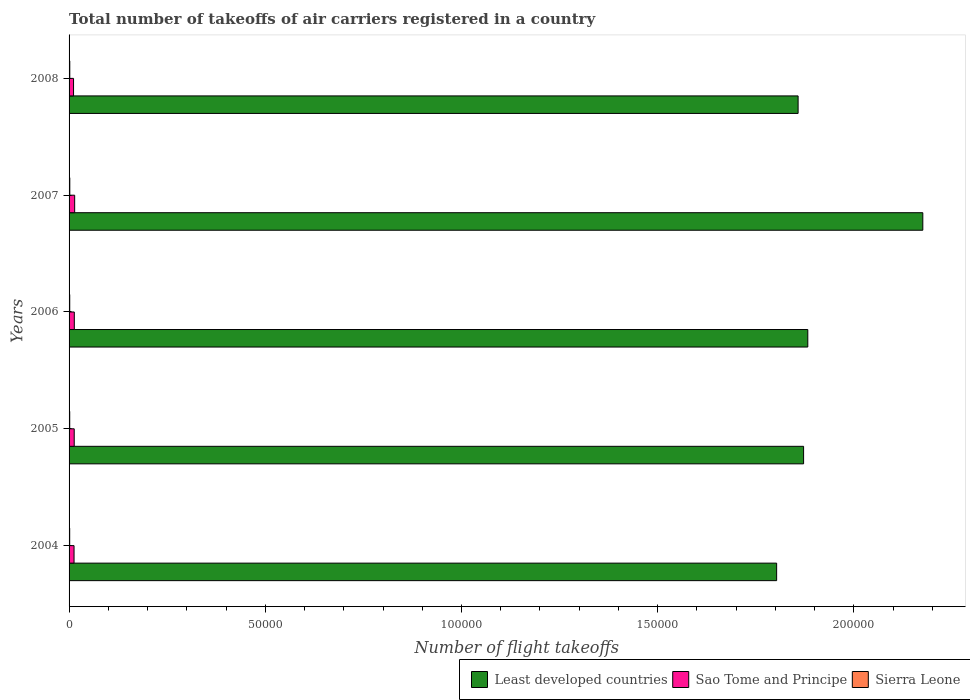How many groups of bars are there?
Offer a terse response. 5. Are the number of bars per tick equal to the number of legend labels?
Make the answer very short. Yes. Are the number of bars on each tick of the Y-axis equal?
Keep it short and to the point. Yes. How many bars are there on the 2nd tick from the top?
Offer a terse response. 3. How many bars are there on the 3rd tick from the bottom?
Provide a short and direct response. 3. What is the label of the 5th group of bars from the top?
Offer a very short reply. 2004. In how many cases, is the number of bars for a given year not equal to the number of legend labels?
Your answer should be very brief. 0. What is the total number of flight takeoffs in Sierra Leone in 2004?
Keep it short and to the point. 156. Across all years, what is the maximum total number of flight takeoffs in Sao Tome and Principe?
Offer a terse response. 1426. Across all years, what is the minimum total number of flight takeoffs in Least developed countries?
Offer a terse response. 1.80e+05. In which year was the total number of flight takeoffs in Least developed countries maximum?
Keep it short and to the point. 2007. What is the total total number of flight takeoffs in Sierra Leone in the graph?
Make the answer very short. 855. What is the difference between the total number of flight takeoffs in Least developed countries in 2005 and the total number of flight takeoffs in Sao Tome and Principe in 2008?
Your response must be concise. 1.86e+05. What is the average total number of flight takeoffs in Sao Tome and Principe per year?
Give a very brief answer. 1296.4. In the year 2006, what is the difference between the total number of flight takeoffs in Sao Tome and Principe and total number of flight takeoffs in Least developed countries?
Make the answer very short. -1.87e+05. In how many years, is the total number of flight takeoffs in Sierra Leone greater than 160000 ?
Your answer should be compact. 0. What is the ratio of the total number of flight takeoffs in Sierra Leone in 2005 to that in 2008?
Give a very brief answer. 0.91. Is the total number of flight takeoffs in Least developed countries in 2007 less than that in 2008?
Offer a very short reply. No. What is the difference between the highest and the second highest total number of flight takeoffs in Sao Tome and Principe?
Keep it short and to the point. 89. What is the difference between the highest and the lowest total number of flight takeoffs in Sao Tome and Principe?
Give a very brief answer. 284. Is the sum of the total number of flight takeoffs in Sao Tome and Principe in 2004 and 2005 greater than the maximum total number of flight takeoffs in Sierra Leone across all years?
Ensure brevity in your answer.  Yes. What does the 3rd bar from the top in 2007 represents?
Offer a very short reply. Least developed countries. What does the 2nd bar from the bottom in 2004 represents?
Your answer should be very brief. Sao Tome and Principe. Is it the case that in every year, the sum of the total number of flight takeoffs in Sierra Leone and total number of flight takeoffs in Sao Tome and Principe is greater than the total number of flight takeoffs in Least developed countries?
Keep it short and to the point. No. How many bars are there?
Make the answer very short. 15. Does the graph contain any zero values?
Give a very brief answer. No. Where does the legend appear in the graph?
Ensure brevity in your answer.  Bottom right. How are the legend labels stacked?
Ensure brevity in your answer.  Horizontal. What is the title of the graph?
Offer a very short reply. Total number of takeoffs of air carriers registered in a country. What is the label or title of the X-axis?
Provide a succinct answer. Number of flight takeoffs. What is the Number of flight takeoffs in Least developed countries in 2004?
Ensure brevity in your answer.  1.80e+05. What is the Number of flight takeoffs of Sao Tome and Principe in 2004?
Give a very brief answer. 1267. What is the Number of flight takeoffs in Sierra Leone in 2004?
Ensure brevity in your answer.  156. What is the Number of flight takeoffs of Least developed countries in 2005?
Provide a succinct answer. 1.87e+05. What is the Number of flight takeoffs in Sao Tome and Principe in 2005?
Provide a succinct answer. 1310. What is the Number of flight takeoffs in Sierra Leone in 2005?
Make the answer very short. 164. What is the Number of flight takeoffs in Least developed countries in 2006?
Give a very brief answer. 1.88e+05. What is the Number of flight takeoffs in Sao Tome and Principe in 2006?
Provide a short and direct response. 1337. What is the Number of flight takeoffs of Sierra Leone in 2006?
Provide a succinct answer. 171. What is the Number of flight takeoffs in Least developed countries in 2007?
Give a very brief answer. 2.18e+05. What is the Number of flight takeoffs in Sao Tome and Principe in 2007?
Offer a very short reply. 1426. What is the Number of flight takeoffs of Sierra Leone in 2007?
Offer a terse response. 183. What is the Number of flight takeoffs of Least developed countries in 2008?
Your answer should be very brief. 1.86e+05. What is the Number of flight takeoffs in Sao Tome and Principe in 2008?
Ensure brevity in your answer.  1142. What is the Number of flight takeoffs in Sierra Leone in 2008?
Provide a short and direct response. 181. Across all years, what is the maximum Number of flight takeoffs in Least developed countries?
Offer a very short reply. 2.18e+05. Across all years, what is the maximum Number of flight takeoffs in Sao Tome and Principe?
Offer a very short reply. 1426. Across all years, what is the maximum Number of flight takeoffs in Sierra Leone?
Offer a terse response. 183. Across all years, what is the minimum Number of flight takeoffs in Least developed countries?
Make the answer very short. 1.80e+05. Across all years, what is the minimum Number of flight takeoffs in Sao Tome and Principe?
Offer a terse response. 1142. Across all years, what is the minimum Number of flight takeoffs in Sierra Leone?
Offer a terse response. 156. What is the total Number of flight takeoffs in Least developed countries in the graph?
Provide a succinct answer. 9.59e+05. What is the total Number of flight takeoffs of Sao Tome and Principe in the graph?
Provide a succinct answer. 6482. What is the total Number of flight takeoffs of Sierra Leone in the graph?
Your response must be concise. 855. What is the difference between the Number of flight takeoffs in Least developed countries in 2004 and that in 2005?
Keep it short and to the point. -6869. What is the difference between the Number of flight takeoffs of Sao Tome and Principe in 2004 and that in 2005?
Ensure brevity in your answer.  -43. What is the difference between the Number of flight takeoffs in Least developed countries in 2004 and that in 2006?
Make the answer very short. -7943. What is the difference between the Number of flight takeoffs of Sao Tome and Principe in 2004 and that in 2006?
Offer a terse response. -70. What is the difference between the Number of flight takeoffs of Sierra Leone in 2004 and that in 2006?
Offer a very short reply. -15. What is the difference between the Number of flight takeoffs in Least developed countries in 2004 and that in 2007?
Ensure brevity in your answer.  -3.72e+04. What is the difference between the Number of flight takeoffs in Sao Tome and Principe in 2004 and that in 2007?
Make the answer very short. -159. What is the difference between the Number of flight takeoffs of Least developed countries in 2004 and that in 2008?
Provide a succinct answer. -5471. What is the difference between the Number of flight takeoffs in Sao Tome and Principe in 2004 and that in 2008?
Ensure brevity in your answer.  125. What is the difference between the Number of flight takeoffs in Sierra Leone in 2004 and that in 2008?
Offer a very short reply. -25. What is the difference between the Number of flight takeoffs of Least developed countries in 2005 and that in 2006?
Offer a terse response. -1074. What is the difference between the Number of flight takeoffs of Sao Tome and Principe in 2005 and that in 2006?
Offer a very short reply. -27. What is the difference between the Number of flight takeoffs in Least developed countries in 2005 and that in 2007?
Your answer should be very brief. -3.04e+04. What is the difference between the Number of flight takeoffs of Sao Tome and Principe in 2005 and that in 2007?
Keep it short and to the point. -116. What is the difference between the Number of flight takeoffs in Sierra Leone in 2005 and that in 2007?
Give a very brief answer. -19. What is the difference between the Number of flight takeoffs of Least developed countries in 2005 and that in 2008?
Provide a short and direct response. 1398. What is the difference between the Number of flight takeoffs in Sao Tome and Principe in 2005 and that in 2008?
Your answer should be very brief. 168. What is the difference between the Number of flight takeoffs in Sierra Leone in 2005 and that in 2008?
Provide a short and direct response. -17. What is the difference between the Number of flight takeoffs of Least developed countries in 2006 and that in 2007?
Offer a very short reply. -2.93e+04. What is the difference between the Number of flight takeoffs in Sao Tome and Principe in 2006 and that in 2007?
Your answer should be very brief. -89. What is the difference between the Number of flight takeoffs in Least developed countries in 2006 and that in 2008?
Make the answer very short. 2472. What is the difference between the Number of flight takeoffs of Sao Tome and Principe in 2006 and that in 2008?
Provide a short and direct response. 195. What is the difference between the Number of flight takeoffs in Sierra Leone in 2006 and that in 2008?
Make the answer very short. -10. What is the difference between the Number of flight takeoffs in Least developed countries in 2007 and that in 2008?
Provide a succinct answer. 3.18e+04. What is the difference between the Number of flight takeoffs of Sao Tome and Principe in 2007 and that in 2008?
Provide a succinct answer. 284. What is the difference between the Number of flight takeoffs of Least developed countries in 2004 and the Number of flight takeoffs of Sao Tome and Principe in 2005?
Provide a short and direct response. 1.79e+05. What is the difference between the Number of flight takeoffs in Least developed countries in 2004 and the Number of flight takeoffs in Sierra Leone in 2005?
Ensure brevity in your answer.  1.80e+05. What is the difference between the Number of flight takeoffs of Sao Tome and Principe in 2004 and the Number of flight takeoffs of Sierra Leone in 2005?
Your answer should be very brief. 1103. What is the difference between the Number of flight takeoffs of Least developed countries in 2004 and the Number of flight takeoffs of Sao Tome and Principe in 2006?
Provide a short and direct response. 1.79e+05. What is the difference between the Number of flight takeoffs of Least developed countries in 2004 and the Number of flight takeoffs of Sierra Leone in 2006?
Your answer should be compact. 1.80e+05. What is the difference between the Number of flight takeoffs in Sao Tome and Principe in 2004 and the Number of flight takeoffs in Sierra Leone in 2006?
Give a very brief answer. 1096. What is the difference between the Number of flight takeoffs of Least developed countries in 2004 and the Number of flight takeoffs of Sao Tome and Principe in 2007?
Provide a short and direct response. 1.79e+05. What is the difference between the Number of flight takeoffs of Least developed countries in 2004 and the Number of flight takeoffs of Sierra Leone in 2007?
Offer a very short reply. 1.80e+05. What is the difference between the Number of flight takeoffs in Sao Tome and Principe in 2004 and the Number of flight takeoffs in Sierra Leone in 2007?
Your answer should be very brief. 1084. What is the difference between the Number of flight takeoffs of Least developed countries in 2004 and the Number of flight takeoffs of Sao Tome and Principe in 2008?
Your answer should be compact. 1.79e+05. What is the difference between the Number of flight takeoffs in Least developed countries in 2004 and the Number of flight takeoffs in Sierra Leone in 2008?
Your answer should be compact. 1.80e+05. What is the difference between the Number of flight takeoffs of Sao Tome and Principe in 2004 and the Number of flight takeoffs of Sierra Leone in 2008?
Keep it short and to the point. 1086. What is the difference between the Number of flight takeoffs of Least developed countries in 2005 and the Number of flight takeoffs of Sao Tome and Principe in 2006?
Your answer should be very brief. 1.86e+05. What is the difference between the Number of flight takeoffs of Least developed countries in 2005 and the Number of flight takeoffs of Sierra Leone in 2006?
Your answer should be compact. 1.87e+05. What is the difference between the Number of flight takeoffs of Sao Tome and Principe in 2005 and the Number of flight takeoffs of Sierra Leone in 2006?
Offer a very short reply. 1139. What is the difference between the Number of flight takeoffs in Least developed countries in 2005 and the Number of flight takeoffs in Sao Tome and Principe in 2007?
Keep it short and to the point. 1.86e+05. What is the difference between the Number of flight takeoffs in Least developed countries in 2005 and the Number of flight takeoffs in Sierra Leone in 2007?
Make the answer very short. 1.87e+05. What is the difference between the Number of flight takeoffs of Sao Tome and Principe in 2005 and the Number of flight takeoffs of Sierra Leone in 2007?
Your answer should be very brief. 1127. What is the difference between the Number of flight takeoffs in Least developed countries in 2005 and the Number of flight takeoffs in Sao Tome and Principe in 2008?
Make the answer very short. 1.86e+05. What is the difference between the Number of flight takeoffs of Least developed countries in 2005 and the Number of flight takeoffs of Sierra Leone in 2008?
Provide a short and direct response. 1.87e+05. What is the difference between the Number of flight takeoffs in Sao Tome and Principe in 2005 and the Number of flight takeoffs in Sierra Leone in 2008?
Ensure brevity in your answer.  1129. What is the difference between the Number of flight takeoffs of Least developed countries in 2006 and the Number of flight takeoffs of Sao Tome and Principe in 2007?
Keep it short and to the point. 1.87e+05. What is the difference between the Number of flight takeoffs of Least developed countries in 2006 and the Number of flight takeoffs of Sierra Leone in 2007?
Your answer should be very brief. 1.88e+05. What is the difference between the Number of flight takeoffs of Sao Tome and Principe in 2006 and the Number of flight takeoffs of Sierra Leone in 2007?
Make the answer very short. 1154. What is the difference between the Number of flight takeoffs in Least developed countries in 2006 and the Number of flight takeoffs in Sao Tome and Principe in 2008?
Give a very brief answer. 1.87e+05. What is the difference between the Number of flight takeoffs in Least developed countries in 2006 and the Number of flight takeoffs in Sierra Leone in 2008?
Offer a terse response. 1.88e+05. What is the difference between the Number of flight takeoffs of Sao Tome and Principe in 2006 and the Number of flight takeoffs of Sierra Leone in 2008?
Offer a terse response. 1156. What is the difference between the Number of flight takeoffs in Least developed countries in 2007 and the Number of flight takeoffs in Sao Tome and Principe in 2008?
Provide a succinct answer. 2.16e+05. What is the difference between the Number of flight takeoffs of Least developed countries in 2007 and the Number of flight takeoffs of Sierra Leone in 2008?
Give a very brief answer. 2.17e+05. What is the difference between the Number of flight takeoffs in Sao Tome and Principe in 2007 and the Number of flight takeoffs in Sierra Leone in 2008?
Your answer should be compact. 1245. What is the average Number of flight takeoffs in Least developed countries per year?
Offer a very short reply. 1.92e+05. What is the average Number of flight takeoffs in Sao Tome and Principe per year?
Make the answer very short. 1296.4. What is the average Number of flight takeoffs of Sierra Leone per year?
Offer a very short reply. 171. In the year 2004, what is the difference between the Number of flight takeoffs in Least developed countries and Number of flight takeoffs in Sao Tome and Principe?
Offer a terse response. 1.79e+05. In the year 2004, what is the difference between the Number of flight takeoffs in Least developed countries and Number of flight takeoffs in Sierra Leone?
Give a very brief answer. 1.80e+05. In the year 2004, what is the difference between the Number of flight takeoffs of Sao Tome and Principe and Number of flight takeoffs of Sierra Leone?
Offer a terse response. 1111. In the year 2005, what is the difference between the Number of flight takeoffs in Least developed countries and Number of flight takeoffs in Sao Tome and Principe?
Your response must be concise. 1.86e+05. In the year 2005, what is the difference between the Number of flight takeoffs in Least developed countries and Number of flight takeoffs in Sierra Leone?
Offer a very short reply. 1.87e+05. In the year 2005, what is the difference between the Number of flight takeoffs of Sao Tome and Principe and Number of flight takeoffs of Sierra Leone?
Ensure brevity in your answer.  1146. In the year 2006, what is the difference between the Number of flight takeoffs of Least developed countries and Number of flight takeoffs of Sao Tome and Principe?
Offer a terse response. 1.87e+05. In the year 2006, what is the difference between the Number of flight takeoffs of Least developed countries and Number of flight takeoffs of Sierra Leone?
Keep it short and to the point. 1.88e+05. In the year 2006, what is the difference between the Number of flight takeoffs of Sao Tome and Principe and Number of flight takeoffs of Sierra Leone?
Offer a very short reply. 1166. In the year 2007, what is the difference between the Number of flight takeoffs in Least developed countries and Number of flight takeoffs in Sao Tome and Principe?
Give a very brief answer. 2.16e+05. In the year 2007, what is the difference between the Number of flight takeoffs in Least developed countries and Number of flight takeoffs in Sierra Leone?
Your answer should be compact. 2.17e+05. In the year 2007, what is the difference between the Number of flight takeoffs of Sao Tome and Principe and Number of flight takeoffs of Sierra Leone?
Give a very brief answer. 1243. In the year 2008, what is the difference between the Number of flight takeoffs of Least developed countries and Number of flight takeoffs of Sao Tome and Principe?
Provide a short and direct response. 1.85e+05. In the year 2008, what is the difference between the Number of flight takeoffs in Least developed countries and Number of flight takeoffs in Sierra Leone?
Provide a succinct answer. 1.86e+05. In the year 2008, what is the difference between the Number of flight takeoffs in Sao Tome and Principe and Number of flight takeoffs in Sierra Leone?
Provide a short and direct response. 961. What is the ratio of the Number of flight takeoffs in Least developed countries in 2004 to that in 2005?
Keep it short and to the point. 0.96. What is the ratio of the Number of flight takeoffs in Sao Tome and Principe in 2004 to that in 2005?
Make the answer very short. 0.97. What is the ratio of the Number of flight takeoffs of Sierra Leone in 2004 to that in 2005?
Provide a short and direct response. 0.95. What is the ratio of the Number of flight takeoffs in Least developed countries in 2004 to that in 2006?
Your answer should be compact. 0.96. What is the ratio of the Number of flight takeoffs in Sao Tome and Principe in 2004 to that in 2006?
Your answer should be very brief. 0.95. What is the ratio of the Number of flight takeoffs in Sierra Leone in 2004 to that in 2006?
Offer a very short reply. 0.91. What is the ratio of the Number of flight takeoffs of Least developed countries in 2004 to that in 2007?
Your response must be concise. 0.83. What is the ratio of the Number of flight takeoffs of Sao Tome and Principe in 2004 to that in 2007?
Your answer should be compact. 0.89. What is the ratio of the Number of flight takeoffs of Sierra Leone in 2004 to that in 2007?
Your answer should be very brief. 0.85. What is the ratio of the Number of flight takeoffs in Least developed countries in 2004 to that in 2008?
Give a very brief answer. 0.97. What is the ratio of the Number of flight takeoffs of Sao Tome and Principe in 2004 to that in 2008?
Offer a very short reply. 1.11. What is the ratio of the Number of flight takeoffs of Sierra Leone in 2004 to that in 2008?
Your answer should be very brief. 0.86. What is the ratio of the Number of flight takeoffs in Sao Tome and Principe in 2005 to that in 2006?
Offer a terse response. 0.98. What is the ratio of the Number of flight takeoffs of Sierra Leone in 2005 to that in 2006?
Give a very brief answer. 0.96. What is the ratio of the Number of flight takeoffs of Least developed countries in 2005 to that in 2007?
Give a very brief answer. 0.86. What is the ratio of the Number of flight takeoffs of Sao Tome and Principe in 2005 to that in 2007?
Your answer should be compact. 0.92. What is the ratio of the Number of flight takeoffs of Sierra Leone in 2005 to that in 2007?
Your answer should be compact. 0.9. What is the ratio of the Number of flight takeoffs in Least developed countries in 2005 to that in 2008?
Offer a terse response. 1.01. What is the ratio of the Number of flight takeoffs of Sao Tome and Principe in 2005 to that in 2008?
Provide a succinct answer. 1.15. What is the ratio of the Number of flight takeoffs of Sierra Leone in 2005 to that in 2008?
Offer a very short reply. 0.91. What is the ratio of the Number of flight takeoffs of Least developed countries in 2006 to that in 2007?
Make the answer very short. 0.87. What is the ratio of the Number of flight takeoffs in Sao Tome and Principe in 2006 to that in 2007?
Your answer should be very brief. 0.94. What is the ratio of the Number of flight takeoffs of Sierra Leone in 2006 to that in 2007?
Provide a short and direct response. 0.93. What is the ratio of the Number of flight takeoffs of Least developed countries in 2006 to that in 2008?
Provide a short and direct response. 1.01. What is the ratio of the Number of flight takeoffs of Sao Tome and Principe in 2006 to that in 2008?
Your answer should be very brief. 1.17. What is the ratio of the Number of flight takeoffs in Sierra Leone in 2006 to that in 2008?
Make the answer very short. 0.94. What is the ratio of the Number of flight takeoffs of Least developed countries in 2007 to that in 2008?
Offer a terse response. 1.17. What is the ratio of the Number of flight takeoffs of Sao Tome and Principe in 2007 to that in 2008?
Offer a terse response. 1.25. What is the ratio of the Number of flight takeoffs of Sierra Leone in 2007 to that in 2008?
Your answer should be very brief. 1.01. What is the difference between the highest and the second highest Number of flight takeoffs of Least developed countries?
Make the answer very short. 2.93e+04. What is the difference between the highest and the second highest Number of flight takeoffs in Sao Tome and Principe?
Offer a very short reply. 89. What is the difference between the highest and the lowest Number of flight takeoffs of Least developed countries?
Offer a terse response. 3.72e+04. What is the difference between the highest and the lowest Number of flight takeoffs in Sao Tome and Principe?
Provide a short and direct response. 284. What is the difference between the highest and the lowest Number of flight takeoffs of Sierra Leone?
Give a very brief answer. 27. 